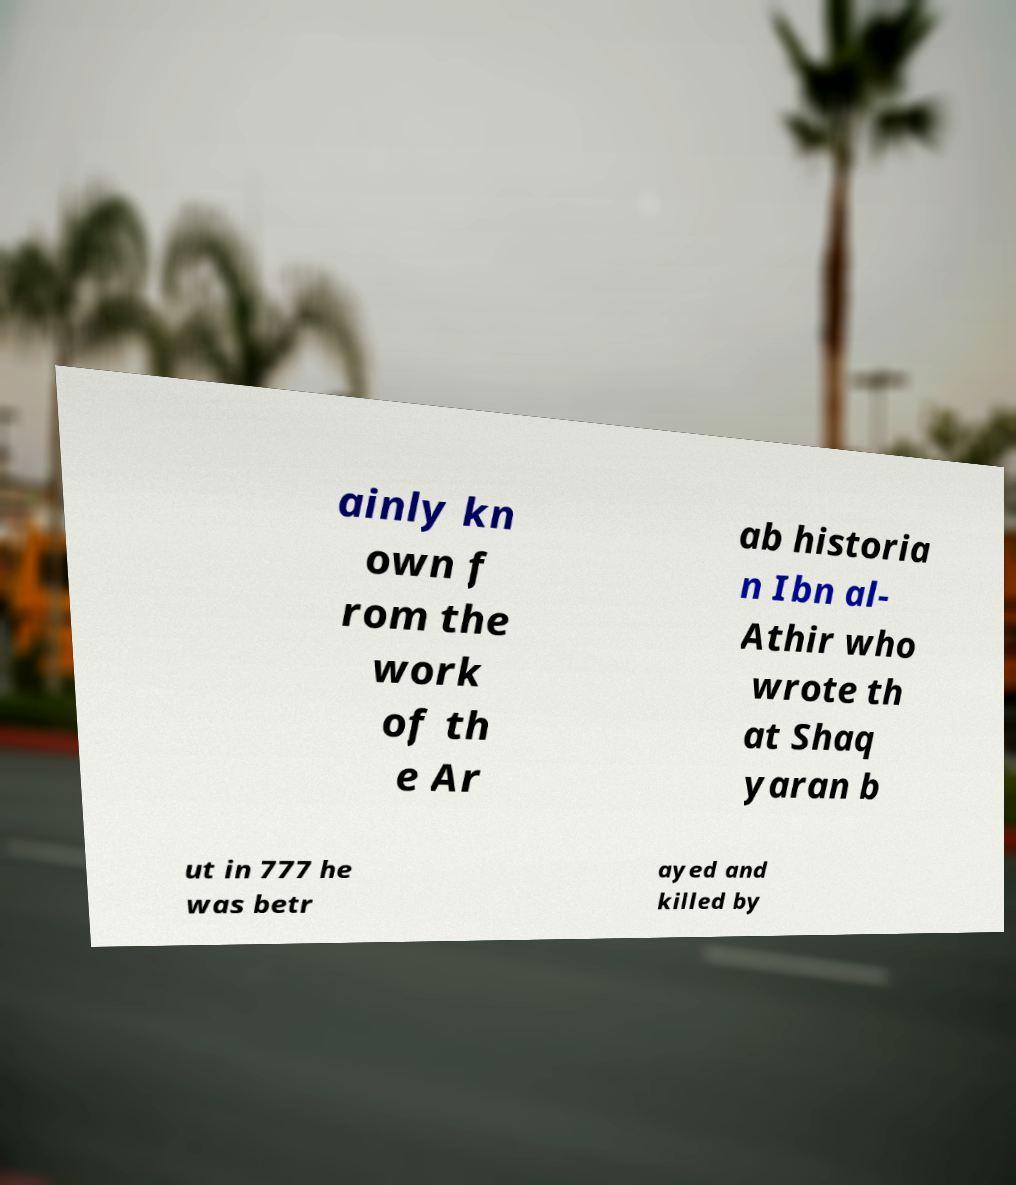Can you read and provide the text displayed in the image?This photo seems to have some interesting text. Can you extract and type it out for me? ainly kn own f rom the work of th e Ar ab historia n Ibn al- Athir who wrote th at Shaq yaran b ut in 777 he was betr ayed and killed by 